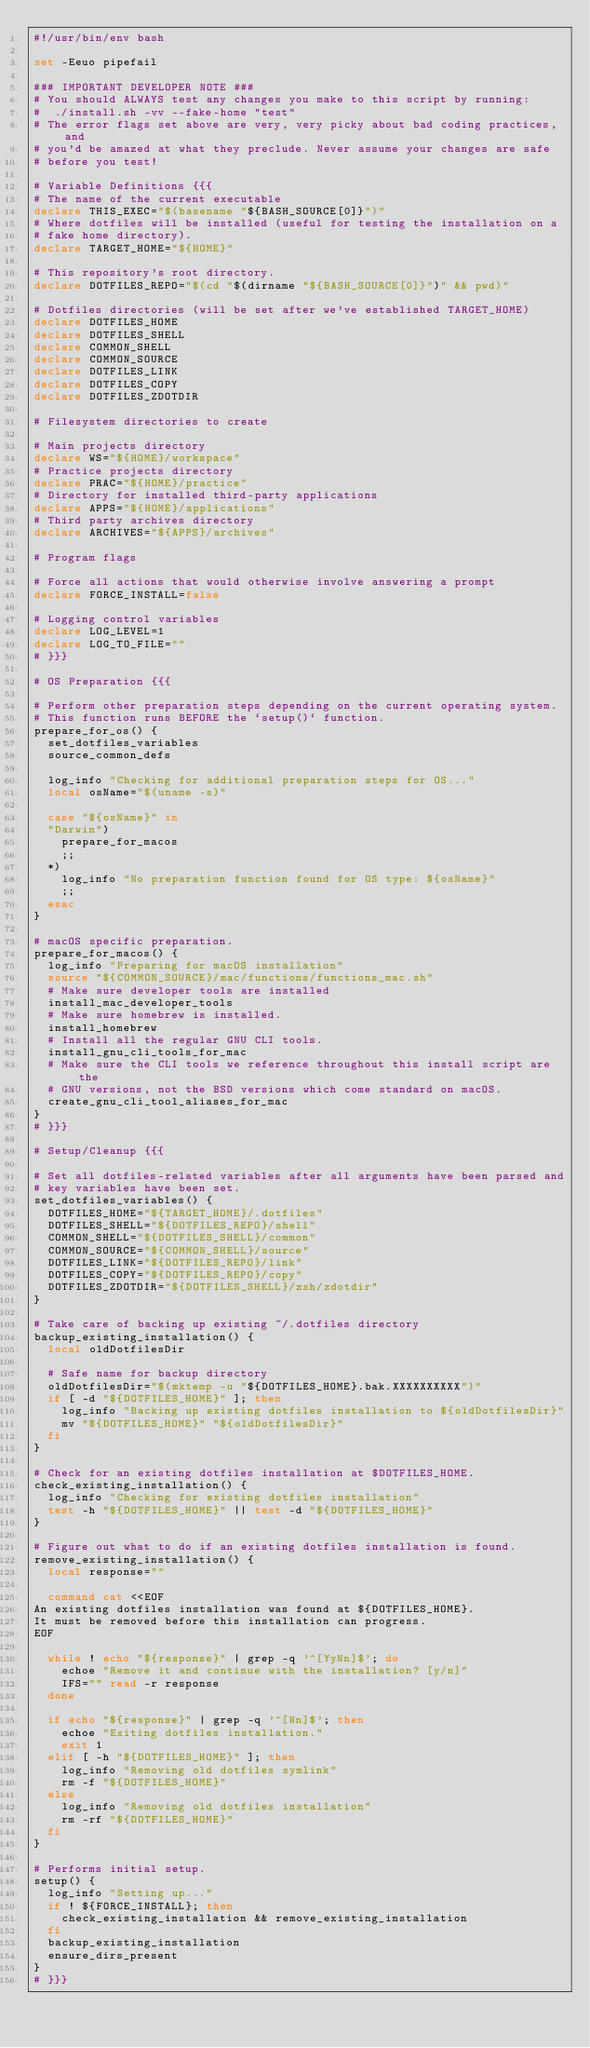Convert code to text. <code><loc_0><loc_0><loc_500><loc_500><_Bash_>#!/usr/bin/env bash

set -Eeuo pipefail

### IMPORTANT DEVELOPER NOTE ###
# You should ALWAYS test any changes you make to this script by running:
#  ./install.sh -vv --fake-home "test"
# The error flags set above are very, very picky about bad coding practices, and
# you'd be amazed at what they preclude. Never assume your changes are safe
# before you test!

# Variable Definitions {{{
# The name of the current executable
declare THIS_EXEC="$(basename "${BASH_SOURCE[0]}")"
# Where dotfiles will be installed (useful for testing the installation on a
# fake home directory).
declare TARGET_HOME="${HOME}"

# This repository's root directory.
declare DOTFILES_REPO="$(cd "$(dirname "${BASH_SOURCE[0]}")" && pwd)"

# Dotfiles directories (will be set after we've established TARGET_HOME)
declare DOTFILES_HOME
declare DOTFILES_SHELL
declare COMMON_SHELL
declare COMMON_SOURCE
declare DOTFILES_LINK
declare DOTFILES_COPY
declare DOTFILES_ZDOTDIR

# Filesystem directories to create

# Main projects directory
declare WS="${HOME}/workspace"
# Practice projects directory
declare PRAC="${HOME}/practice"
# Directory for installed third-party applications
declare APPS="${HOME}/applications"
# Third party archives directory
declare ARCHIVES="${APPS}/archives"

# Program flags

# Force all actions that would otherwise involve answering a prompt
declare FORCE_INSTALL=false

# Logging control variables
declare LOG_LEVEL=1
declare LOG_TO_FILE=""
# }}}

# OS Preparation {{{

# Perform other preparation steps depending on the current operating system.
# This function runs BEFORE the `setup()` function.
prepare_for_os() {
  set_dotfiles_variables
  source_common_defs

  log_info "Checking for additional preparation steps for OS..."
  local osName="$(uname -s)"

  case "${osName}" in
  "Darwin")
    prepare_for_macos
    ;;
  *)
    log_info "No preparation function found for OS type: ${osName}"
    ;;
  esac
}

# macOS specific preparation.
prepare_for_macos() {
  log_info "Preparing for macOS installation"
  source "${COMMON_SOURCE}/mac/functions/functions_mac.sh"
  # Make sure developer tools are installed
  install_mac_developer_tools
  # Make sure homebrew is installed.
  install_homebrew
  # Install all the regular GNU CLI tools.
  install_gnu_cli_tools_for_mac
  # Make sure the CLI tools we reference throughout this install script are the
  # GNU versions, not the BSD versions which come standard on macOS.
  create_gnu_cli_tool_aliases_for_mac
}
# }}}

# Setup/Cleanup {{{

# Set all dotfiles-related variables after all arguments have been parsed and
# key variables have been set.
set_dotfiles_variables() {
  DOTFILES_HOME="${TARGET_HOME}/.dotfiles"
  DOTFILES_SHELL="${DOTFILES_REPO}/shell"
  COMMON_SHELL="${DOTFILES_SHELL}/common"
  COMMON_SOURCE="${COMMON_SHELL}/source"
  DOTFILES_LINK="${DOTFILES_REPO}/link"
  DOTFILES_COPY="${DOTFILES_REPO}/copy"
  DOTFILES_ZDOTDIR="${DOTFILES_SHELL}/zsh/zdotdir"
}

# Take care of backing up existing ~/.dotfiles directory
backup_existing_installation() {
  local oldDotfilesDir

  # Safe name for backup directory
  oldDotfilesDir="$(mktemp -u "${DOTFILES_HOME}.bak.XXXXXXXXXX")"
  if [ -d "${DOTFILES_HOME}" ]; then
    log_info "Backing up existing dotfiles installation to ${oldDotfilesDir}"
    mv "${DOTFILES_HOME}" "${oldDotfilesDir}"
  fi
}

# Check for an existing dotfiles installation at $DOTFILES_HOME.
check_existing_installation() {
  log_info "Checking for existing dotfiles installation"
  test -h "${DOTFILES_HOME}" || test -d "${DOTFILES_HOME}"
}

# Figure out what to do if an existing dotfiles installation is found.
remove_existing_installation() {
  local response=""

  command cat <<EOF
An existing dotfiles installation was found at ${DOTFILES_HOME}.
It must be removed before this installation can progress.
EOF

  while ! echo "${response}" | grep -q '^[YyNn]$'; do
    echoe "Remove it and continue with the installation? [y/n]"
    IFS="" read -r response
  done

  if echo "${response}" | grep -q '^[Nn]$'; then
    echoe "Exiting dotfiles installation."
    exit 1
  elif [ -h "${DOTFILES_HOME}" ]; then
    log_info "Removing old dotfiles symlink"
    rm -f "${DOTFILES_HOME}"
  else
    log_info "Removing old dotfiles installation"
    rm -rf "${DOTFILES_HOME}"
  fi
}

# Performs initial setup.
setup() {
  log_info "Setting up..."
  if ! ${FORCE_INSTALL}; then
    check_existing_installation && remove_existing_installation
  fi
  backup_existing_installation
  ensure_dirs_present
}
# }}}
</code> 